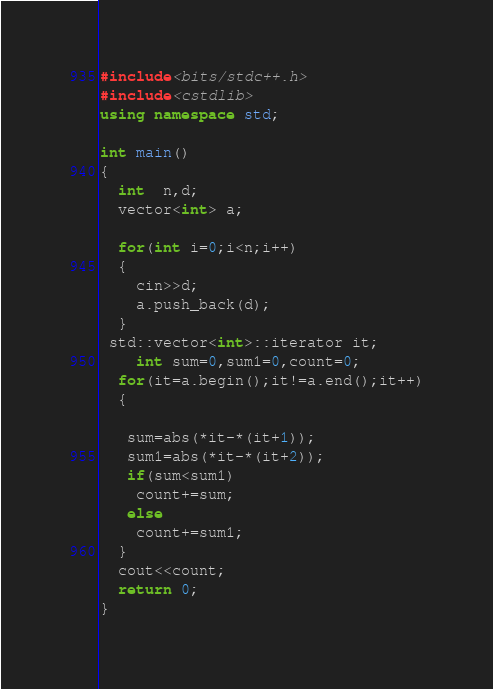<code> <loc_0><loc_0><loc_500><loc_500><_C++_>#include<bits/stdc++.h>
#include<cstdlib>
using namespace std;

int main()
{
  int  n,d;
  vector<int> a;
 
  for(int i=0;i<n;i++)
  {
  	cin>>d;
    a.push_back(d);
  }
 std::vector<int>::iterator it;
	int sum=0,sum1=0,count=0;
  for(it=a.begin();it!=a.end();it++)
  {
   
   sum=abs(*it-*(it+1));
   sum1=abs(*it-*(it+2));
   if(sum<sum1)
   	count+=sum;
   else
    count+=sum1;
  }
  cout<<count;
  return 0;
}</code> 